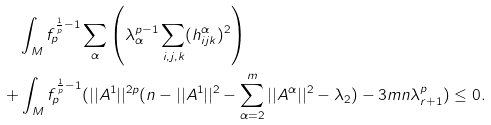Convert formula to latex. <formula><loc_0><loc_0><loc_500><loc_500>& \quad \int _ { M } f _ { p } ^ { \frac { 1 } { p } - 1 } \sum _ { \alpha } \left ( \lambda _ { \alpha } ^ { p - 1 } \sum _ { i , j , k } ( h _ { i j k } ^ { \alpha } ) ^ { 2 } \right ) \\ & + \int _ { M } f _ { p } ^ { \frac { 1 } { p } - 1 } ( | | A ^ { 1 } | | ^ { 2 p } ( n - | | A ^ { 1 } | | ^ { 2 } - \sum _ { \alpha = 2 } ^ { m } | | A ^ { \alpha } | | ^ { 2 } - \lambda _ { 2 } ) - 3 m n \lambda _ { r + 1 } ^ { p } ) \leq 0 .</formula> 